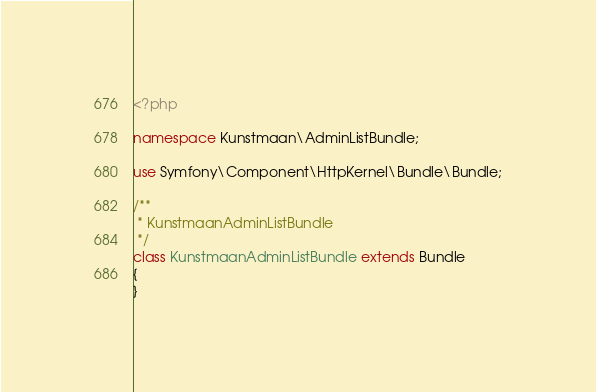Convert code to text. <code><loc_0><loc_0><loc_500><loc_500><_PHP_><?php

namespace Kunstmaan\AdminListBundle;

use Symfony\Component\HttpKernel\Bundle\Bundle;

/**
 * KunstmaanAdminListBundle
 */
class KunstmaanAdminListBundle extends Bundle
{
}
</code> 